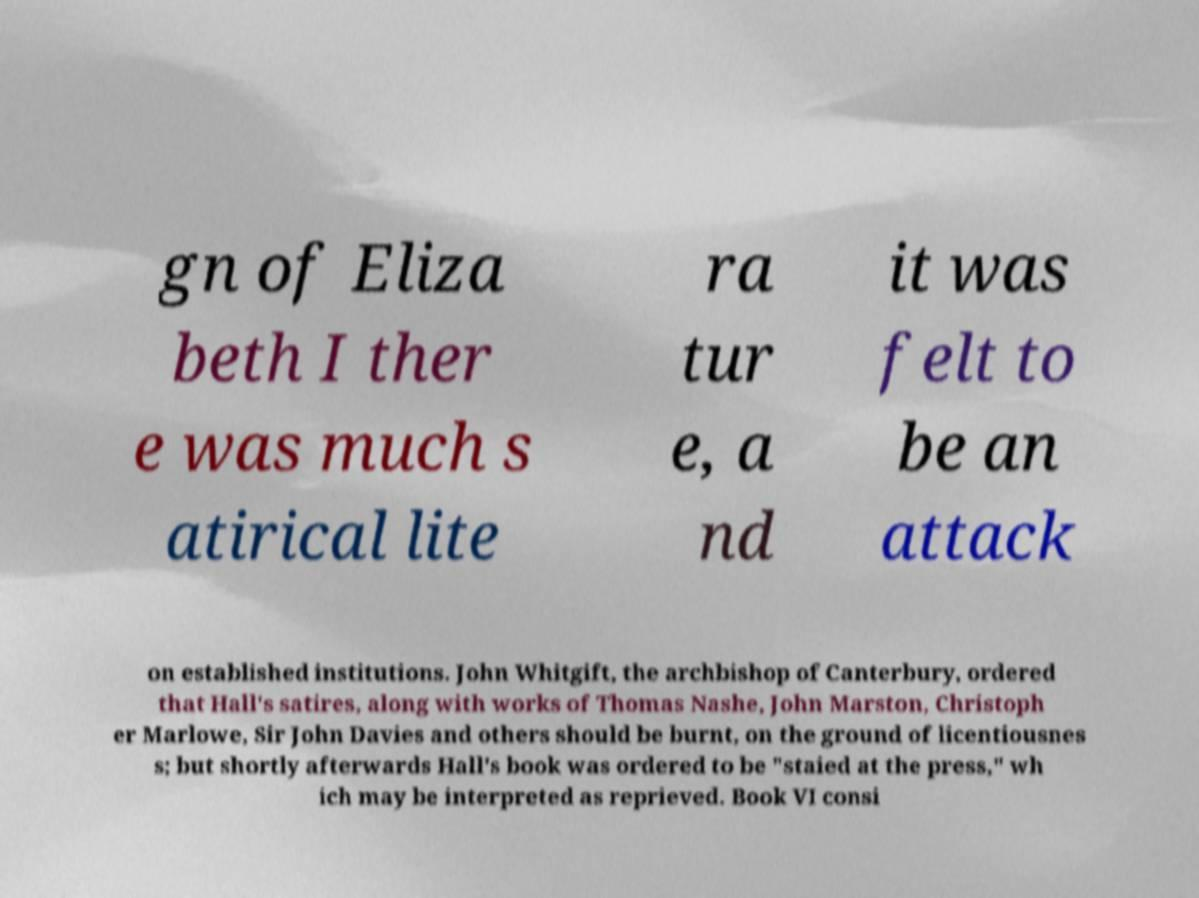Can you read and provide the text displayed in the image?This photo seems to have some interesting text. Can you extract and type it out for me? gn of Eliza beth I ther e was much s atirical lite ra tur e, a nd it was felt to be an attack on established institutions. John Whitgift, the archbishop of Canterbury, ordered that Hall's satires, along with works of Thomas Nashe, John Marston, Christoph er Marlowe, Sir John Davies and others should be burnt, on the ground of licentiousnes s; but shortly afterwards Hall's book was ordered to be "staied at the press," wh ich may be interpreted as reprieved. Book VI consi 